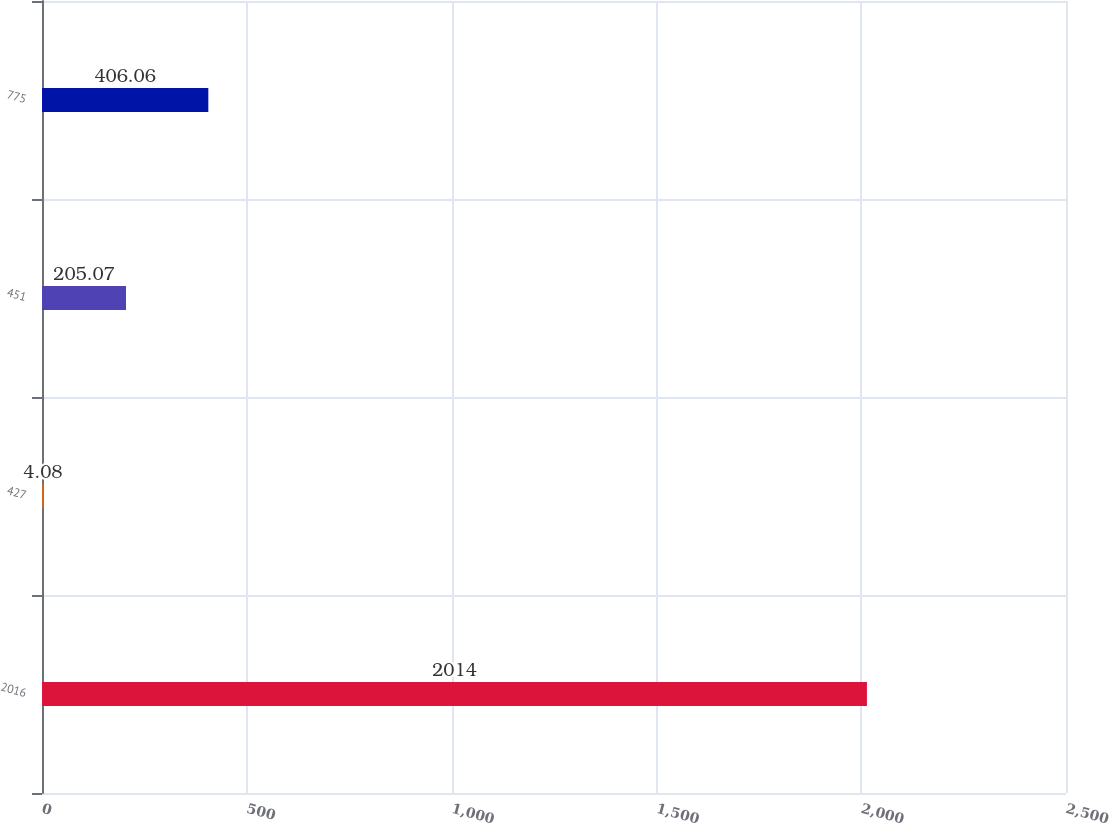<chart> <loc_0><loc_0><loc_500><loc_500><bar_chart><fcel>2016<fcel>427<fcel>451<fcel>775<nl><fcel>2014<fcel>4.08<fcel>205.07<fcel>406.06<nl></chart> 